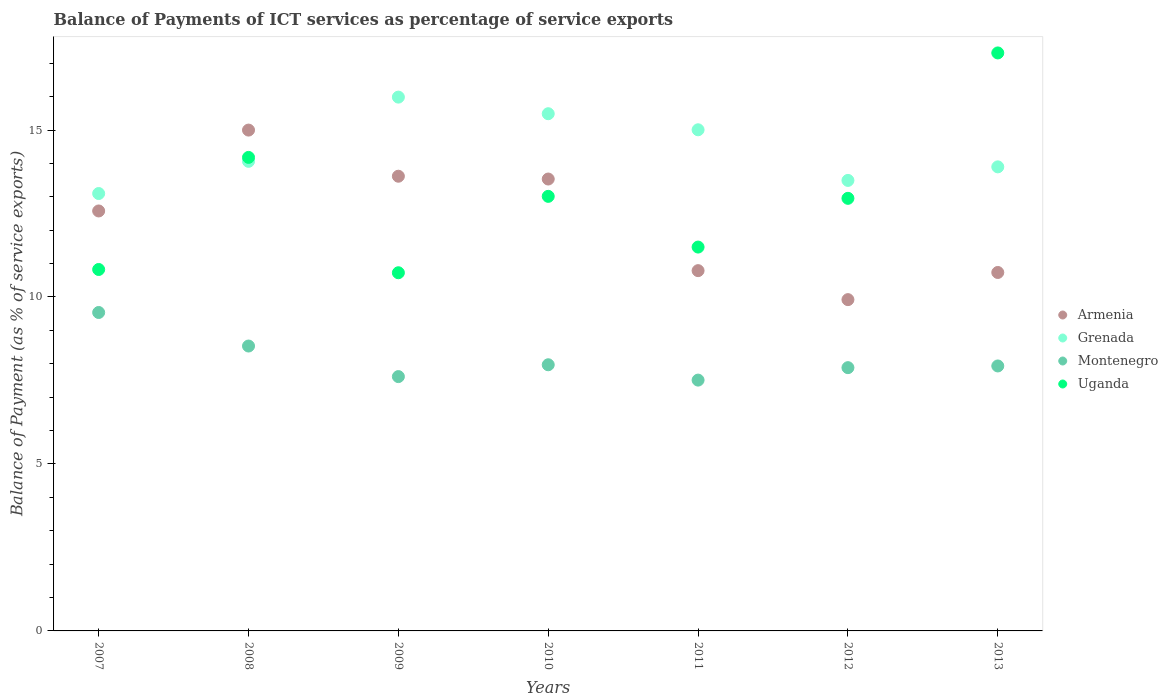How many different coloured dotlines are there?
Your answer should be very brief. 4. What is the balance of payments of ICT services in Uganda in 2013?
Your response must be concise. 17.31. Across all years, what is the maximum balance of payments of ICT services in Armenia?
Provide a short and direct response. 15. Across all years, what is the minimum balance of payments of ICT services in Montenegro?
Provide a short and direct response. 7.51. In which year was the balance of payments of ICT services in Armenia maximum?
Give a very brief answer. 2008. What is the total balance of payments of ICT services in Armenia in the graph?
Offer a very short reply. 86.17. What is the difference between the balance of payments of ICT services in Grenada in 2011 and that in 2012?
Keep it short and to the point. 1.52. What is the difference between the balance of payments of ICT services in Grenada in 2013 and the balance of payments of ICT services in Montenegro in 2007?
Provide a succinct answer. 4.36. What is the average balance of payments of ICT services in Armenia per year?
Your response must be concise. 12.31. In the year 2009, what is the difference between the balance of payments of ICT services in Montenegro and balance of payments of ICT services in Uganda?
Keep it short and to the point. -3.11. In how many years, is the balance of payments of ICT services in Grenada greater than 9 %?
Make the answer very short. 7. What is the ratio of the balance of payments of ICT services in Armenia in 2011 to that in 2012?
Keep it short and to the point. 1.09. Is the balance of payments of ICT services in Grenada in 2009 less than that in 2012?
Make the answer very short. No. Is the difference between the balance of payments of ICT services in Montenegro in 2008 and 2011 greater than the difference between the balance of payments of ICT services in Uganda in 2008 and 2011?
Your answer should be very brief. No. What is the difference between the highest and the second highest balance of payments of ICT services in Grenada?
Provide a short and direct response. 0.5. What is the difference between the highest and the lowest balance of payments of ICT services in Grenada?
Your answer should be compact. 2.89. Is the sum of the balance of payments of ICT services in Uganda in 2009 and 2010 greater than the maximum balance of payments of ICT services in Grenada across all years?
Provide a succinct answer. Yes. Is it the case that in every year, the sum of the balance of payments of ICT services in Montenegro and balance of payments of ICT services in Grenada  is greater than the balance of payments of ICT services in Uganda?
Offer a terse response. Yes. Does the balance of payments of ICT services in Montenegro monotonically increase over the years?
Your answer should be very brief. No. Is the balance of payments of ICT services in Armenia strictly less than the balance of payments of ICT services in Grenada over the years?
Offer a very short reply. No. What is the difference between two consecutive major ticks on the Y-axis?
Give a very brief answer. 5. Are the values on the major ticks of Y-axis written in scientific E-notation?
Your answer should be very brief. No. Where does the legend appear in the graph?
Keep it short and to the point. Center right. What is the title of the graph?
Provide a succinct answer. Balance of Payments of ICT services as percentage of service exports. Does "Hungary" appear as one of the legend labels in the graph?
Your answer should be compact. No. What is the label or title of the Y-axis?
Your answer should be very brief. Balance of Payment (as % of service exports). What is the Balance of Payment (as % of service exports) of Armenia in 2007?
Offer a very short reply. 12.58. What is the Balance of Payment (as % of service exports) of Grenada in 2007?
Offer a terse response. 13.1. What is the Balance of Payment (as % of service exports) of Montenegro in 2007?
Your answer should be compact. 9.54. What is the Balance of Payment (as % of service exports) in Uganda in 2007?
Offer a terse response. 10.82. What is the Balance of Payment (as % of service exports) in Armenia in 2008?
Keep it short and to the point. 15. What is the Balance of Payment (as % of service exports) in Grenada in 2008?
Ensure brevity in your answer.  14.06. What is the Balance of Payment (as % of service exports) in Montenegro in 2008?
Make the answer very short. 8.53. What is the Balance of Payment (as % of service exports) in Uganda in 2008?
Offer a very short reply. 14.18. What is the Balance of Payment (as % of service exports) in Armenia in 2009?
Give a very brief answer. 13.62. What is the Balance of Payment (as % of service exports) in Grenada in 2009?
Ensure brevity in your answer.  15.99. What is the Balance of Payment (as % of service exports) of Montenegro in 2009?
Keep it short and to the point. 7.62. What is the Balance of Payment (as % of service exports) of Uganda in 2009?
Your response must be concise. 10.73. What is the Balance of Payment (as % of service exports) in Armenia in 2010?
Keep it short and to the point. 13.53. What is the Balance of Payment (as % of service exports) in Grenada in 2010?
Keep it short and to the point. 15.49. What is the Balance of Payment (as % of service exports) in Montenegro in 2010?
Offer a terse response. 7.97. What is the Balance of Payment (as % of service exports) of Uganda in 2010?
Give a very brief answer. 13.01. What is the Balance of Payment (as % of service exports) of Armenia in 2011?
Provide a succinct answer. 10.79. What is the Balance of Payment (as % of service exports) in Grenada in 2011?
Your response must be concise. 15.01. What is the Balance of Payment (as % of service exports) of Montenegro in 2011?
Ensure brevity in your answer.  7.51. What is the Balance of Payment (as % of service exports) in Uganda in 2011?
Your answer should be compact. 11.49. What is the Balance of Payment (as % of service exports) in Armenia in 2012?
Ensure brevity in your answer.  9.92. What is the Balance of Payment (as % of service exports) of Grenada in 2012?
Ensure brevity in your answer.  13.49. What is the Balance of Payment (as % of service exports) in Montenegro in 2012?
Provide a succinct answer. 7.88. What is the Balance of Payment (as % of service exports) of Uganda in 2012?
Your response must be concise. 12.95. What is the Balance of Payment (as % of service exports) in Armenia in 2013?
Provide a succinct answer. 10.73. What is the Balance of Payment (as % of service exports) of Grenada in 2013?
Ensure brevity in your answer.  13.9. What is the Balance of Payment (as % of service exports) in Montenegro in 2013?
Provide a short and direct response. 7.93. What is the Balance of Payment (as % of service exports) of Uganda in 2013?
Give a very brief answer. 17.31. Across all years, what is the maximum Balance of Payment (as % of service exports) of Armenia?
Offer a very short reply. 15. Across all years, what is the maximum Balance of Payment (as % of service exports) of Grenada?
Provide a succinct answer. 15.99. Across all years, what is the maximum Balance of Payment (as % of service exports) in Montenegro?
Give a very brief answer. 9.54. Across all years, what is the maximum Balance of Payment (as % of service exports) of Uganda?
Your answer should be compact. 17.31. Across all years, what is the minimum Balance of Payment (as % of service exports) in Armenia?
Keep it short and to the point. 9.92. Across all years, what is the minimum Balance of Payment (as % of service exports) in Grenada?
Offer a very short reply. 13.1. Across all years, what is the minimum Balance of Payment (as % of service exports) in Montenegro?
Provide a succinct answer. 7.51. Across all years, what is the minimum Balance of Payment (as % of service exports) of Uganda?
Your answer should be compact. 10.73. What is the total Balance of Payment (as % of service exports) in Armenia in the graph?
Provide a short and direct response. 86.17. What is the total Balance of Payment (as % of service exports) in Grenada in the graph?
Offer a terse response. 101.03. What is the total Balance of Payment (as % of service exports) in Montenegro in the graph?
Provide a short and direct response. 56.98. What is the total Balance of Payment (as % of service exports) in Uganda in the graph?
Keep it short and to the point. 90.5. What is the difference between the Balance of Payment (as % of service exports) in Armenia in 2007 and that in 2008?
Offer a terse response. -2.42. What is the difference between the Balance of Payment (as % of service exports) in Grenada in 2007 and that in 2008?
Keep it short and to the point. -0.96. What is the difference between the Balance of Payment (as % of service exports) of Montenegro in 2007 and that in 2008?
Keep it short and to the point. 1. What is the difference between the Balance of Payment (as % of service exports) of Uganda in 2007 and that in 2008?
Provide a succinct answer. -3.36. What is the difference between the Balance of Payment (as % of service exports) of Armenia in 2007 and that in 2009?
Ensure brevity in your answer.  -1.04. What is the difference between the Balance of Payment (as % of service exports) in Grenada in 2007 and that in 2009?
Provide a short and direct response. -2.89. What is the difference between the Balance of Payment (as % of service exports) in Montenegro in 2007 and that in 2009?
Provide a succinct answer. 1.92. What is the difference between the Balance of Payment (as % of service exports) in Uganda in 2007 and that in 2009?
Your answer should be compact. 0.1. What is the difference between the Balance of Payment (as % of service exports) of Armenia in 2007 and that in 2010?
Ensure brevity in your answer.  -0.96. What is the difference between the Balance of Payment (as % of service exports) of Grenada in 2007 and that in 2010?
Provide a short and direct response. -2.39. What is the difference between the Balance of Payment (as % of service exports) in Montenegro in 2007 and that in 2010?
Your answer should be very brief. 1.57. What is the difference between the Balance of Payment (as % of service exports) in Uganda in 2007 and that in 2010?
Offer a very short reply. -2.19. What is the difference between the Balance of Payment (as % of service exports) in Armenia in 2007 and that in 2011?
Ensure brevity in your answer.  1.79. What is the difference between the Balance of Payment (as % of service exports) in Grenada in 2007 and that in 2011?
Offer a very short reply. -1.91. What is the difference between the Balance of Payment (as % of service exports) of Montenegro in 2007 and that in 2011?
Offer a terse response. 2.02. What is the difference between the Balance of Payment (as % of service exports) of Uganda in 2007 and that in 2011?
Provide a succinct answer. -0.67. What is the difference between the Balance of Payment (as % of service exports) in Armenia in 2007 and that in 2012?
Provide a succinct answer. 2.66. What is the difference between the Balance of Payment (as % of service exports) of Grenada in 2007 and that in 2012?
Offer a terse response. -0.39. What is the difference between the Balance of Payment (as % of service exports) of Montenegro in 2007 and that in 2012?
Give a very brief answer. 1.65. What is the difference between the Balance of Payment (as % of service exports) in Uganda in 2007 and that in 2012?
Ensure brevity in your answer.  -2.13. What is the difference between the Balance of Payment (as % of service exports) of Armenia in 2007 and that in 2013?
Offer a terse response. 1.84. What is the difference between the Balance of Payment (as % of service exports) in Grenada in 2007 and that in 2013?
Your response must be concise. -0.8. What is the difference between the Balance of Payment (as % of service exports) in Montenegro in 2007 and that in 2013?
Your response must be concise. 1.6. What is the difference between the Balance of Payment (as % of service exports) of Uganda in 2007 and that in 2013?
Provide a succinct answer. -6.49. What is the difference between the Balance of Payment (as % of service exports) in Armenia in 2008 and that in 2009?
Keep it short and to the point. 1.38. What is the difference between the Balance of Payment (as % of service exports) in Grenada in 2008 and that in 2009?
Keep it short and to the point. -1.92. What is the difference between the Balance of Payment (as % of service exports) of Montenegro in 2008 and that in 2009?
Offer a terse response. 0.92. What is the difference between the Balance of Payment (as % of service exports) in Uganda in 2008 and that in 2009?
Your response must be concise. 3.45. What is the difference between the Balance of Payment (as % of service exports) of Armenia in 2008 and that in 2010?
Your answer should be very brief. 1.47. What is the difference between the Balance of Payment (as % of service exports) in Grenada in 2008 and that in 2010?
Provide a short and direct response. -1.43. What is the difference between the Balance of Payment (as % of service exports) of Montenegro in 2008 and that in 2010?
Give a very brief answer. 0.56. What is the difference between the Balance of Payment (as % of service exports) of Armenia in 2008 and that in 2011?
Your response must be concise. 4.21. What is the difference between the Balance of Payment (as % of service exports) of Grenada in 2008 and that in 2011?
Your response must be concise. -0.94. What is the difference between the Balance of Payment (as % of service exports) in Montenegro in 2008 and that in 2011?
Your answer should be very brief. 1.02. What is the difference between the Balance of Payment (as % of service exports) in Uganda in 2008 and that in 2011?
Your answer should be compact. 2.69. What is the difference between the Balance of Payment (as % of service exports) of Armenia in 2008 and that in 2012?
Offer a terse response. 5.08. What is the difference between the Balance of Payment (as % of service exports) in Grenada in 2008 and that in 2012?
Keep it short and to the point. 0.57. What is the difference between the Balance of Payment (as % of service exports) in Montenegro in 2008 and that in 2012?
Keep it short and to the point. 0.65. What is the difference between the Balance of Payment (as % of service exports) of Uganda in 2008 and that in 2012?
Provide a succinct answer. 1.23. What is the difference between the Balance of Payment (as % of service exports) in Armenia in 2008 and that in 2013?
Offer a terse response. 4.26. What is the difference between the Balance of Payment (as % of service exports) in Grenada in 2008 and that in 2013?
Your answer should be very brief. 0.17. What is the difference between the Balance of Payment (as % of service exports) in Montenegro in 2008 and that in 2013?
Make the answer very short. 0.6. What is the difference between the Balance of Payment (as % of service exports) in Uganda in 2008 and that in 2013?
Give a very brief answer. -3.13. What is the difference between the Balance of Payment (as % of service exports) of Armenia in 2009 and that in 2010?
Your answer should be very brief. 0.08. What is the difference between the Balance of Payment (as % of service exports) of Grenada in 2009 and that in 2010?
Your answer should be very brief. 0.5. What is the difference between the Balance of Payment (as % of service exports) of Montenegro in 2009 and that in 2010?
Your answer should be compact. -0.35. What is the difference between the Balance of Payment (as % of service exports) in Uganda in 2009 and that in 2010?
Give a very brief answer. -2.29. What is the difference between the Balance of Payment (as % of service exports) of Armenia in 2009 and that in 2011?
Give a very brief answer. 2.83. What is the difference between the Balance of Payment (as % of service exports) of Grenada in 2009 and that in 2011?
Offer a very short reply. 0.98. What is the difference between the Balance of Payment (as % of service exports) in Montenegro in 2009 and that in 2011?
Your response must be concise. 0.11. What is the difference between the Balance of Payment (as % of service exports) in Uganda in 2009 and that in 2011?
Give a very brief answer. -0.77. What is the difference between the Balance of Payment (as % of service exports) of Armenia in 2009 and that in 2012?
Provide a short and direct response. 3.7. What is the difference between the Balance of Payment (as % of service exports) of Grenada in 2009 and that in 2012?
Keep it short and to the point. 2.49. What is the difference between the Balance of Payment (as % of service exports) of Montenegro in 2009 and that in 2012?
Provide a short and direct response. -0.27. What is the difference between the Balance of Payment (as % of service exports) of Uganda in 2009 and that in 2012?
Your answer should be compact. -2.23. What is the difference between the Balance of Payment (as % of service exports) of Armenia in 2009 and that in 2013?
Your response must be concise. 2.88. What is the difference between the Balance of Payment (as % of service exports) of Grenada in 2009 and that in 2013?
Provide a succinct answer. 2.09. What is the difference between the Balance of Payment (as % of service exports) in Montenegro in 2009 and that in 2013?
Keep it short and to the point. -0.32. What is the difference between the Balance of Payment (as % of service exports) of Uganda in 2009 and that in 2013?
Offer a very short reply. -6.58. What is the difference between the Balance of Payment (as % of service exports) in Armenia in 2010 and that in 2011?
Offer a terse response. 2.74. What is the difference between the Balance of Payment (as % of service exports) in Grenada in 2010 and that in 2011?
Make the answer very short. 0.48. What is the difference between the Balance of Payment (as % of service exports) in Montenegro in 2010 and that in 2011?
Make the answer very short. 0.46. What is the difference between the Balance of Payment (as % of service exports) in Uganda in 2010 and that in 2011?
Make the answer very short. 1.52. What is the difference between the Balance of Payment (as % of service exports) in Armenia in 2010 and that in 2012?
Make the answer very short. 3.61. What is the difference between the Balance of Payment (as % of service exports) in Grenada in 2010 and that in 2012?
Keep it short and to the point. 2. What is the difference between the Balance of Payment (as % of service exports) of Montenegro in 2010 and that in 2012?
Your answer should be very brief. 0.09. What is the difference between the Balance of Payment (as % of service exports) of Uganda in 2010 and that in 2012?
Make the answer very short. 0.06. What is the difference between the Balance of Payment (as % of service exports) in Armenia in 2010 and that in 2013?
Your answer should be very brief. 2.8. What is the difference between the Balance of Payment (as % of service exports) of Grenada in 2010 and that in 2013?
Your answer should be compact. 1.59. What is the difference between the Balance of Payment (as % of service exports) of Montenegro in 2010 and that in 2013?
Your response must be concise. 0.04. What is the difference between the Balance of Payment (as % of service exports) in Uganda in 2010 and that in 2013?
Ensure brevity in your answer.  -4.29. What is the difference between the Balance of Payment (as % of service exports) in Armenia in 2011 and that in 2012?
Provide a succinct answer. 0.87. What is the difference between the Balance of Payment (as % of service exports) in Grenada in 2011 and that in 2012?
Give a very brief answer. 1.52. What is the difference between the Balance of Payment (as % of service exports) in Montenegro in 2011 and that in 2012?
Provide a short and direct response. -0.37. What is the difference between the Balance of Payment (as % of service exports) in Uganda in 2011 and that in 2012?
Offer a very short reply. -1.46. What is the difference between the Balance of Payment (as % of service exports) in Armenia in 2011 and that in 2013?
Keep it short and to the point. 0.05. What is the difference between the Balance of Payment (as % of service exports) in Grenada in 2011 and that in 2013?
Offer a very short reply. 1.11. What is the difference between the Balance of Payment (as % of service exports) of Montenegro in 2011 and that in 2013?
Offer a very short reply. -0.42. What is the difference between the Balance of Payment (as % of service exports) in Uganda in 2011 and that in 2013?
Ensure brevity in your answer.  -5.81. What is the difference between the Balance of Payment (as % of service exports) in Armenia in 2012 and that in 2013?
Offer a terse response. -0.81. What is the difference between the Balance of Payment (as % of service exports) in Grenada in 2012 and that in 2013?
Offer a very short reply. -0.41. What is the difference between the Balance of Payment (as % of service exports) in Montenegro in 2012 and that in 2013?
Provide a short and direct response. -0.05. What is the difference between the Balance of Payment (as % of service exports) of Uganda in 2012 and that in 2013?
Your response must be concise. -4.35. What is the difference between the Balance of Payment (as % of service exports) of Armenia in 2007 and the Balance of Payment (as % of service exports) of Grenada in 2008?
Your answer should be compact. -1.49. What is the difference between the Balance of Payment (as % of service exports) in Armenia in 2007 and the Balance of Payment (as % of service exports) in Montenegro in 2008?
Provide a short and direct response. 4.04. What is the difference between the Balance of Payment (as % of service exports) in Armenia in 2007 and the Balance of Payment (as % of service exports) in Uganda in 2008?
Give a very brief answer. -1.6. What is the difference between the Balance of Payment (as % of service exports) of Grenada in 2007 and the Balance of Payment (as % of service exports) of Montenegro in 2008?
Offer a very short reply. 4.57. What is the difference between the Balance of Payment (as % of service exports) in Grenada in 2007 and the Balance of Payment (as % of service exports) in Uganda in 2008?
Make the answer very short. -1.08. What is the difference between the Balance of Payment (as % of service exports) in Montenegro in 2007 and the Balance of Payment (as % of service exports) in Uganda in 2008?
Give a very brief answer. -4.64. What is the difference between the Balance of Payment (as % of service exports) of Armenia in 2007 and the Balance of Payment (as % of service exports) of Grenada in 2009?
Your response must be concise. -3.41. What is the difference between the Balance of Payment (as % of service exports) in Armenia in 2007 and the Balance of Payment (as % of service exports) in Montenegro in 2009?
Provide a short and direct response. 4.96. What is the difference between the Balance of Payment (as % of service exports) of Armenia in 2007 and the Balance of Payment (as % of service exports) of Uganda in 2009?
Offer a very short reply. 1.85. What is the difference between the Balance of Payment (as % of service exports) of Grenada in 2007 and the Balance of Payment (as % of service exports) of Montenegro in 2009?
Your answer should be very brief. 5.48. What is the difference between the Balance of Payment (as % of service exports) in Grenada in 2007 and the Balance of Payment (as % of service exports) in Uganda in 2009?
Your answer should be very brief. 2.37. What is the difference between the Balance of Payment (as % of service exports) in Montenegro in 2007 and the Balance of Payment (as % of service exports) in Uganda in 2009?
Your answer should be very brief. -1.19. What is the difference between the Balance of Payment (as % of service exports) of Armenia in 2007 and the Balance of Payment (as % of service exports) of Grenada in 2010?
Provide a short and direct response. -2.91. What is the difference between the Balance of Payment (as % of service exports) of Armenia in 2007 and the Balance of Payment (as % of service exports) of Montenegro in 2010?
Make the answer very short. 4.61. What is the difference between the Balance of Payment (as % of service exports) in Armenia in 2007 and the Balance of Payment (as % of service exports) in Uganda in 2010?
Provide a succinct answer. -0.44. What is the difference between the Balance of Payment (as % of service exports) in Grenada in 2007 and the Balance of Payment (as % of service exports) in Montenegro in 2010?
Keep it short and to the point. 5.13. What is the difference between the Balance of Payment (as % of service exports) in Grenada in 2007 and the Balance of Payment (as % of service exports) in Uganda in 2010?
Your answer should be compact. 0.08. What is the difference between the Balance of Payment (as % of service exports) in Montenegro in 2007 and the Balance of Payment (as % of service exports) in Uganda in 2010?
Ensure brevity in your answer.  -3.48. What is the difference between the Balance of Payment (as % of service exports) of Armenia in 2007 and the Balance of Payment (as % of service exports) of Grenada in 2011?
Provide a succinct answer. -2.43. What is the difference between the Balance of Payment (as % of service exports) in Armenia in 2007 and the Balance of Payment (as % of service exports) in Montenegro in 2011?
Provide a succinct answer. 5.07. What is the difference between the Balance of Payment (as % of service exports) in Armenia in 2007 and the Balance of Payment (as % of service exports) in Uganda in 2011?
Your response must be concise. 1.08. What is the difference between the Balance of Payment (as % of service exports) of Grenada in 2007 and the Balance of Payment (as % of service exports) of Montenegro in 2011?
Offer a terse response. 5.59. What is the difference between the Balance of Payment (as % of service exports) of Grenada in 2007 and the Balance of Payment (as % of service exports) of Uganda in 2011?
Provide a short and direct response. 1.6. What is the difference between the Balance of Payment (as % of service exports) of Montenegro in 2007 and the Balance of Payment (as % of service exports) of Uganda in 2011?
Offer a very short reply. -1.96. What is the difference between the Balance of Payment (as % of service exports) of Armenia in 2007 and the Balance of Payment (as % of service exports) of Grenada in 2012?
Your answer should be very brief. -0.91. What is the difference between the Balance of Payment (as % of service exports) in Armenia in 2007 and the Balance of Payment (as % of service exports) in Montenegro in 2012?
Give a very brief answer. 4.69. What is the difference between the Balance of Payment (as % of service exports) of Armenia in 2007 and the Balance of Payment (as % of service exports) of Uganda in 2012?
Provide a short and direct response. -0.38. What is the difference between the Balance of Payment (as % of service exports) of Grenada in 2007 and the Balance of Payment (as % of service exports) of Montenegro in 2012?
Provide a short and direct response. 5.21. What is the difference between the Balance of Payment (as % of service exports) in Grenada in 2007 and the Balance of Payment (as % of service exports) in Uganda in 2012?
Ensure brevity in your answer.  0.14. What is the difference between the Balance of Payment (as % of service exports) in Montenegro in 2007 and the Balance of Payment (as % of service exports) in Uganda in 2012?
Provide a succinct answer. -3.42. What is the difference between the Balance of Payment (as % of service exports) of Armenia in 2007 and the Balance of Payment (as % of service exports) of Grenada in 2013?
Your response must be concise. -1.32. What is the difference between the Balance of Payment (as % of service exports) of Armenia in 2007 and the Balance of Payment (as % of service exports) of Montenegro in 2013?
Offer a very short reply. 4.64. What is the difference between the Balance of Payment (as % of service exports) of Armenia in 2007 and the Balance of Payment (as % of service exports) of Uganda in 2013?
Ensure brevity in your answer.  -4.73. What is the difference between the Balance of Payment (as % of service exports) in Grenada in 2007 and the Balance of Payment (as % of service exports) in Montenegro in 2013?
Your response must be concise. 5.16. What is the difference between the Balance of Payment (as % of service exports) of Grenada in 2007 and the Balance of Payment (as % of service exports) of Uganda in 2013?
Offer a terse response. -4.21. What is the difference between the Balance of Payment (as % of service exports) of Montenegro in 2007 and the Balance of Payment (as % of service exports) of Uganda in 2013?
Your response must be concise. -7.77. What is the difference between the Balance of Payment (as % of service exports) in Armenia in 2008 and the Balance of Payment (as % of service exports) in Grenada in 2009?
Your response must be concise. -0.99. What is the difference between the Balance of Payment (as % of service exports) in Armenia in 2008 and the Balance of Payment (as % of service exports) in Montenegro in 2009?
Ensure brevity in your answer.  7.38. What is the difference between the Balance of Payment (as % of service exports) of Armenia in 2008 and the Balance of Payment (as % of service exports) of Uganda in 2009?
Your answer should be very brief. 4.27. What is the difference between the Balance of Payment (as % of service exports) in Grenada in 2008 and the Balance of Payment (as % of service exports) in Montenegro in 2009?
Provide a succinct answer. 6.45. What is the difference between the Balance of Payment (as % of service exports) in Grenada in 2008 and the Balance of Payment (as % of service exports) in Uganda in 2009?
Offer a very short reply. 3.34. What is the difference between the Balance of Payment (as % of service exports) in Montenegro in 2008 and the Balance of Payment (as % of service exports) in Uganda in 2009?
Keep it short and to the point. -2.19. What is the difference between the Balance of Payment (as % of service exports) in Armenia in 2008 and the Balance of Payment (as % of service exports) in Grenada in 2010?
Your response must be concise. -0.49. What is the difference between the Balance of Payment (as % of service exports) in Armenia in 2008 and the Balance of Payment (as % of service exports) in Montenegro in 2010?
Give a very brief answer. 7.03. What is the difference between the Balance of Payment (as % of service exports) of Armenia in 2008 and the Balance of Payment (as % of service exports) of Uganda in 2010?
Offer a very short reply. 1.98. What is the difference between the Balance of Payment (as % of service exports) in Grenada in 2008 and the Balance of Payment (as % of service exports) in Montenegro in 2010?
Keep it short and to the point. 6.09. What is the difference between the Balance of Payment (as % of service exports) of Grenada in 2008 and the Balance of Payment (as % of service exports) of Uganda in 2010?
Make the answer very short. 1.05. What is the difference between the Balance of Payment (as % of service exports) of Montenegro in 2008 and the Balance of Payment (as % of service exports) of Uganda in 2010?
Your answer should be compact. -4.48. What is the difference between the Balance of Payment (as % of service exports) of Armenia in 2008 and the Balance of Payment (as % of service exports) of Grenada in 2011?
Provide a succinct answer. -0.01. What is the difference between the Balance of Payment (as % of service exports) in Armenia in 2008 and the Balance of Payment (as % of service exports) in Montenegro in 2011?
Provide a succinct answer. 7.49. What is the difference between the Balance of Payment (as % of service exports) of Armenia in 2008 and the Balance of Payment (as % of service exports) of Uganda in 2011?
Keep it short and to the point. 3.5. What is the difference between the Balance of Payment (as % of service exports) of Grenada in 2008 and the Balance of Payment (as % of service exports) of Montenegro in 2011?
Keep it short and to the point. 6.55. What is the difference between the Balance of Payment (as % of service exports) in Grenada in 2008 and the Balance of Payment (as % of service exports) in Uganda in 2011?
Keep it short and to the point. 2.57. What is the difference between the Balance of Payment (as % of service exports) of Montenegro in 2008 and the Balance of Payment (as % of service exports) of Uganda in 2011?
Your response must be concise. -2.96. What is the difference between the Balance of Payment (as % of service exports) in Armenia in 2008 and the Balance of Payment (as % of service exports) in Grenada in 2012?
Offer a terse response. 1.51. What is the difference between the Balance of Payment (as % of service exports) in Armenia in 2008 and the Balance of Payment (as % of service exports) in Montenegro in 2012?
Offer a terse response. 7.11. What is the difference between the Balance of Payment (as % of service exports) in Armenia in 2008 and the Balance of Payment (as % of service exports) in Uganda in 2012?
Provide a succinct answer. 2.04. What is the difference between the Balance of Payment (as % of service exports) in Grenada in 2008 and the Balance of Payment (as % of service exports) in Montenegro in 2012?
Your answer should be very brief. 6.18. What is the difference between the Balance of Payment (as % of service exports) of Grenada in 2008 and the Balance of Payment (as % of service exports) of Uganda in 2012?
Offer a very short reply. 1.11. What is the difference between the Balance of Payment (as % of service exports) of Montenegro in 2008 and the Balance of Payment (as % of service exports) of Uganda in 2012?
Provide a succinct answer. -4.42. What is the difference between the Balance of Payment (as % of service exports) in Armenia in 2008 and the Balance of Payment (as % of service exports) in Grenada in 2013?
Give a very brief answer. 1.1. What is the difference between the Balance of Payment (as % of service exports) of Armenia in 2008 and the Balance of Payment (as % of service exports) of Montenegro in 2013?
Provide a short and direct response. 7.06. What is the difference between the Balance of Payment (as % of service exports) of Armenia in 2008 and the Balance of Payment (as % of service exports) of Uganda in 2013?
Offer a terse response. -2.31. What is the difference between the Balance of Payment (as % of service exports) of Grenada in 2008 and the Balance of Payment (as % of service exports) of Montenegro in 2013?
Offer a terse response. 6.13. What is the difference between the Balance of Payment (as % of service exports) in Grenada in 2008 and the Balance of Payment (as % of service exports) in Uganda in 2013?
Your answer should be very brief. -3.25. What is the difference between the Balance of Payment (as % of service exports) of Montenegro in 2008 and the Balance of Payment (as % of service exports) of Uganda in 2013?
Your response must be concise. -8.78. What is the difference between the Balance of Payment (as % of service exports) in Armenia in 2009 and the Balance of Payment (as % of service exports) in Grenada in 2010?
Your response must be concise. -1.87. What is the difference between the Balance of Payment (as % of service exports) in Armenia in 2009 and the Balance of Payment (as % of service exports) in Montenegro in 2010?
Provide a short and direct response. 5.65. What is the difference between the Balance of Payment (as % of service exports) of Armenia in 2009 and the Balance of Payment (as % of service exports) of Uganda in 2010?
Provide a succinct answer. 0.6. What is the difference between the Balance of Payment (as % of service exports) of Grenada in 2009 and the Balance of Payment (as % of service exports) of Montenegro in 2010?
Your response must be concise. 8.02. What is the difference between the Balance of Payment (as % of service exports) in Grenada in 2009 and the Balance of Payment (as % of service exports) in Uganda in 2010?
Give a very brief answer. 2.97. What is the difference between the Balance of Payment (as % of service exports) in Montenegro in 2009 and the Balance of Payment (as % of service exports) in Uganda in 2010?
Offer a terse response. -5.4. What is the difference between the Balance of Payment (as % of service exports) in Armenia in 2009 and the Balance of Payment (as % of service exports) in Grenada in 2011?
Your answer should be compact. -1.39. What is the difference between the Balance of Payment (as % of service exports) of Armenia in 2009 and the Balance of Payment (as % of service exports) of Montenegro in 2011?
Ensure brevity in your answer.  6.11. What is the difference between the Balance of Payment (as % of service exports) of Armenia in 2009 and the Balance of Payment (as % of service exports) of Uganda in 2011?
Your answer should be compact. 2.12. What is the difference between the Balance of Payment (as % of service exports) in Grenada in 2009 and the Balance of Payment (as % of service exports) in Montenegro in 2011?
Give a very brief answer. 8.47. What is the difference between the Balance of Payment (as % of service exports) of Grenada in 2009 and the Balance of Payment (as % of service exports) of Uganda in 2011?
Provide a succinct answer. 4.49. What is the difference between the Balance of Payment (as % of service exports) of Montenegro in 2009 and the Balance of Payment (as % of service exports) of Uganda in 2011?
Your response must be concise. -3.88. What is the difference between the Balance of Payment (as % of service exports) in Armenia in 2009 and the Balance of Payment (as % of service exports) in Grenada in 2012?
Provide a succinct answer. 0.13. What is the difference between the Balance of Payment (as % of service exports) in Armenia in 2009 and the Balance of Payment (as % of service exports) in Montenegro in 2012?
Your response must be concise. 5.73. What is the difference between the Balance of Payment (as % of service exports) in Armenia in 2009 and the Balance of Payment (as % of service exports) in Uganda in 2012?
Ensure brevity in your answer.  0.66. What is the difference between the Balance of Payment (as % of service exports) in Grenada in 2009 and the Balance of Payment (as % of service exports) in Montenegro in 2012?
Your answer should be compact. 8.1. What is the difference between the Balance of Payment (as % of service exports) in Grenada in 2009 and the Balance of Payment (as % of service exports) in Uganda in 2012?
Ensure brevity in your answer.  3.03. What is the difference between the Balance of Payment (as % of service exports) of Montenegro in 2009 and the Balance of Payment (as % of service exports) of Uganda in 2012?
Your response must be concise. -5.34. What is the difference between the Balance of Payment (as % of service exports) in Armenia in 2009 and the Balance of Payment (as % of service exports) in Grenada in 2013?
Provide a succinct answer. -0.28. What is the difference between the Balance of Payment (as % of service exports) of Armenia in 2009 and the Balance of Payment (as % of service exports) of Montenegro in 2013?
Ensure brevity in your answer.  5.68. What is the difference between the Balance of Payment (as % of service exports) of Armenia in 2009 and the Balance of Payment (as % of service exports) of Uganda in 2013?
Provide a short and direct response. -3.69. What is the difference between the Balance of Payment (as % of service exports) of Grenada in 2009 and the Balance of Payment (as % of service exports) of Montenegro in 2013?
Ensure brevity in your answer.  8.05. What is the difference between the Balance of Payment (as % of service exports) in Grenada in 2009 and the Balance of Payment (as % of service exports) in Uganda in 2013?
Your response must be concise. -1.32. What is the difference between the Balance of Payment (as % of service exports) in Montenegro in 2009 and the Balance of Payment (as % of service exports) in Uganda in 2013?
Keep it short and to the point. -9.69. What is the difference between the Balance of Payment (as % of service exports) in Armenia in 2010 and the Balance of Payment (as % of service exports) in Grenada in 2011?
Keep it short and to the point. -1.47. What is the difference between the Balance of Payment (as % of service exports) in Armenia in 2010 and the Balance of Payment (as % of service exports) in Montenegro in 2011?
Offer a very short reply. 6.02. What is the difference between the Balance of Payment (as % of service exports) of Armenia in 2010 and the Balance of Payment (as % of service exports) of Uganda in 2011?
Offer a terse response. 2.04. What is the difference between the Balance of Payment (as % of service exports) in Grenada in 2010 and the Balance of Payment (as % of service exports) in Montenegro in 2011?
Ensure brevity in your answer.  7.98. What is the difference between the Balance of Payment (as % of service exports) of Grenada in 2010 and the Balance of Payment (as % of service exports) of Uganda in 2011?
Your response must be concise. 3.99. What is the difference between the Balance of Payment (as % of service exports) of Montenegro in 2010 and the Balance of Payment (as % of service exports) of Uganda in 2011?
Your answer should be compact. -3.52. What is the difference between the Balance of Payment (as % of service exports) in Armenia in 2010 and the Balance of Payment (as % of service exports) in Grenada in 2012?
Ensure brevity in your answer.  0.04. What is the difference between the Balance of Payment (as % of service exports) in Armenia in 2010 and the Balance of Payment (as % of service exports) in Montenegro in 2012?
Provide a succinct answer. 5.65. What is the difference between the Balance of Payment (as % of service exports) in Armenia in 2010 and the Balance of Payment (as % of service exports) in Uganda in 2012?
Your answer should be compact. 0.58. What is the difference between the Balance of Payment (as % of service exports) in Grenada in 2010 and the Balance of Payment (as % of service exports) in Montenegro in 2012?
Offer a terse response. 7.6. What is the difference between the Balance of Payment (as % of service exports) in Grenada in 2010 and the Balance of Payment (as % of service exports) in Uganda in 2012?
Your answer should be compact. 2.53. What is the difference between the Balance of Payment (as % of service exports) of Montenegro in 2010 and the Balance of Payment (as % of service exports) of Uganda in 2012?
Your answer should be very brief. -4.98. What is the difference between the Balance of Payment (as % of service exports) of Armenia in 2010 and the Balance of Payment (as % of service exports) of Grenada in 2013?
Provide a succinct answer. -0.36. What is the difference between the Balance of Payment (as % of service exports) of Armenia in 2010 and the Balance of Payment (as % of service exports) of Montenegro in 2013?
Your response must be concise. 5.6. What is the difference between the Balance of Payment (as % of service exports) of Armenia in 2010 and the Balance of Payment (as % of service exports) of Uganda in 2013?
Offer a terse response. -3.78. What is the difference between the Balance of Payment (as % of service exports) in Grenada in 2010 and the Balance of Payment (as % of service exports) in Montenegro in 2013?
Keep it short and to the point. 7.55. What is the difference between the Balance of Payment (as % of service exports) in Grenada in 2010 and the Balance of Payment (as % of service exports) in Uganda in 2013?
Your response must be concise. -1.82. What is the difference between the Balance of Payment (as % of service exports) of Montenegro in 2010 and the Balance of Payment (as % of service exports) of Uganda in 2013?
Your answer should be compact. -9.34. What is the difference between the Balance of Payment (as % of service exports) of Armenia in 2011 and the Balance of Payment (as % of service exports) of Grenada in 2012?
Give a very brief answer. -2.7. What is the difference between the Balance of Payment (as % of service exports) of Armenia in 2011 and the Balance of Payment (as % of service exports) of Montenegro in 2012?
Provide a short and direct response. 2.91. What is the difference between the Balance of Payment (as % of service exports) in Armenia in 2011 and the Balance of Payment (as % of service exports) in Uganda in 2012?
Your answer should be compact. -2.17. What is the difference between the Balance of Payment (as % of service exports) of Grenada in 2011 and the Balance of Payment (as % of service exports) of Montenegro in 2012?
Make the answer very short. 7.12. What is the difference between the Balance of Payment (as % of service exports) of Grenada in 2011 and the Balance of Payment (as % of service exports) of Uganda in 2012?
Provide a short and direct response. 2.05. What is the difference between the Balance of Payment (as % of service exports) of Montenegro in 2011 and the Balance of Payment (as % of service exports) of Uganda in 2012?
Provide a short and direct response. -5.44. What is the difference between the Balance of Payment (as % of service exports) of Armenia in 2011 and the Balance of Payment (as % of service exports) of Grenada in 2013?
Provide a short and direct response. -3.11. What is the difference between the Balance of Payment (as % of service exports) of Armenia in 2011 and the Balance of Payment (as % of service exports) of Montenegro in 2013?
Give a very brief answer. 2.85. What is the difference between the Balance of Payment (as % of service exports) in Armenia in 2011 and the Balance of Payment (as % of service exports) in Uganda in 2013?
Keep it short and to the point. -6.52. What is the difference between the Balance of Payment (as % of service exports) in Grenada in 2011 and the Balance of Payment (as % of service exports) in Montenegro in 2013?
Keep it short and to the point. 7.07. What is the difference between the Balance of Payment (as % of service exports) in Grenada in 2011 and the Balance of Payment (as % of service exports) in Uganda in 2013?
Your response must be concise. -2.3. What is the difference between the Balance of Payment (as % of service exports) in Montenegro in 2011 and the Balance of Payment (as % of service exports) in Uganda in 2013?
Offer a very short reply. -9.8. What is the difference between the Balance of Payment (as % of service exports) of Armenia in 2012 and the Balance of Payment (as % of service exports) of Grenada in 2013?
Offer a terse response. -3.98. What is the difference between the Balance of Payment (as % of service exports) in Armenia in 2012 and the Balance of Payment (as % of service exports) in Montenegro in 2013?
Your response must be concise. 1.99. What is the difference between the Balance of Payment (as % of service exports) in Armenia in 2012 and the Balance of Payment (as % of service exports) in Uganda in 2013?
Offer a terse response. -7.39. What is the difference between the Balance of Payment (as % of service exports) of Grenada in 2012 and the Balance of Payment (as % of service exports) of Montenegro in 2013?
Provide a succinct answer. 5.56. What is the difference between the Balance of Payment (as % of service exports) of Grenada in 2012 and the Balance of Payment (as % of service exports) of Uganda in 2013?
Offer a very short reply. -3.82. What is the difference between the Balance of Payment (as % of service exports) of Montenegro in 2012 and the Balance of Payment (as % of service exports) of Uganda in 2013?
Make the answer very short. -9.42. What is the average Balance of Payment (as % of service exports) in Armenia per year?
Make the answer very short. 12.31. What is the average Balance of Payment (as % of service exports) of Grenada per year?
Provide a succinct answer. 14.43. What is the average Balance of Payment (as % of service exports) of Montenegro per year?
Give a very brief answer. 8.14. What is the average Balance of Payment (as % of service exports) in Uganda per year?
Provide a succinct answer. 12.93. In the year 2007, what is the difference between the Balance of Payment (as % of service exports) in Armenia and Balance of Payment (as % of service exports) in Grenada?
Provide a short and direct response. -0.52. In the year 2007, what is the difference between the Balance of Payment (as % of service exports) of Armenia and Balance of Payment (as % of service exports) of Montenegro?
Provide a short and direct response. 3.04. In the year 2007, what is the difference between the Balance of Payment (as % of service exports) in Armenia and Balance of Payment (as % of service exports) in Uganda?
Offer a terse response. 1.75. In the year 2007, what is the difference between the Balance of Payment (as % of service exports) in Grenada and Balance of Payment (as % of service exports) in Montenegro?
Offer a very short reply. 3.56. In the year 2007, what is the difference between the Balance of Payment (as % of service exports) of Grenada and Balance of Payment (as % of service exports) of Uganda?
Keep it short and to the point. 2.27. In the year 2007, what is the difference between the Balance of Payment (as % of service exports) in Montenegro and Balance of Payment (as % of service exports) in Uganda?
Provide a succinct answer. -1.29. In the year 2008, what is the difference between the Balance of Payment (as % of service exports) of Armenia and Balance of Payment (as % of service exports) of Grenada?
Keep it short and to the point. 0.94. In the year 2008, what is the difference between the Balance of Payment (as % of service exports) of Armenia and Balance of Payment (as % of service exports) of Montenegro?
Provide a succinct answer. 6.47. In the year 2008, what is the difference between the Balance of Payment (as % of service exports) in Armenia and Balance of Payment (as % of service exports) in Uganda?
Give a very brief answer. 0.82. In the year 2008, what is the difference between the Balance of Payment (as % of service exports) of Grenada and Balance of Payment (as % of service exports) of Montenegro?
Give a very brief answer. 5.53. In the year 2008, what is the difference between the Balance of Payment (as % of service exports) of Grenada and Balance of Payment (as % of service exports) of Uganda?
Your response must be concise. -0.12. In the year 2008, what is the difference between the Balance of Payment (as % of service exports) of Montenegro and Balance of Payment (as % of service exports) of Uganda?
Offer a very short reply. -5.65. In the year 2009, what is the difference between the Balance of Payment (as % of service exports) of Armenia and Balance of Payment (as % of service exports) of Grenada?
Provide a succinct answer. -2.37. In the year 2009, what is the difference between the Balance of Payment (as % of service exports) of Armenia and Balance of Payment (as % of service exports) of Montenegro?
Provide a succinct answer. 6. In the year 2009, what is the difference between the Balance of Payment (as % of service exports) in Armenia and Balance of Payment (as % of service exports) in Uganda?
Your response must be concise. 2.89. In the year 2009, what is the difference between the Balance of Payment (as % of service exports) in Grenada and Balance of Payment (as % of service exports) in Montenegro?
Provide a succinct answer. 8.37. In the year 2009, what is the difference between the Balance of Payment (as % of service exports) in Grenada and Balance of Payment (as % of service exports) in Uganda?
Your answer should be very brief. 5.26. In the year 2009, what is the difference between the Balance of Payment (as % of service exports) in Montenegro and Balance of Payment (as % of service exports) in Uganda?
Make the answer very short. -3.11. In the year 2010, what is the difference between the Balance of Payment (as % of service exports) in Armenia and Balance of Payment (as % of service exports) in Grenada?
Your answer should be very brief. -1.96. In the year 2010, what is the difference between the Balance of Payment (as % of service exports) in Armenia and Balance of Payment (as % of service exports) in Montenegro?
Offer a very short reply. 5.56. In the year 2010, what is the difference between the Balance of Payment (as % of service exports) in Armenia and Balance of Payment (as % of service exports) in Uganda?
Make the answer very short. 0.52. In the year 2010, what is the difference between the Balance of Payment (as % of service exports) in Grenada and Balance of Payment (as % of service exports) in Montenegro?
Keep it short and to the point. 7.52. In the year 2010, what is the difference between the Balance of Payment (as % of service exports) of Grenada and Balance of Payment (as % of service exports) of Uganda?
Give a very brief answer. 2.47. In the year 2010, what is the difference between the Balance of Payment (as % of service exports) of Montenegro and Balance of Payment (as % of service exports) of Uganda?
Ensure brevity in your answer.  -5.04. In the year 2011, what is the difference between the Balance of Payment (as % of service exports) in Armenia and Balance of Payment (as % of service exports) in Grenada?
Make the answer very short. -4.22. In the year 2011, what is the difference between the Balance of Payment (as % of service exports) of Armenia and Balance of Payment (as % of service exports) of Montenegro?
Keep it short and to the point. 3.28. In the year 2011, what is the difference between the Balance of Payment (as % of service exports) of Armenia and Balance of Payment (as % of service exports) of Uganda?
Provide a short and direct response. -0.71. In the year 2011, what is the difference between the Balance of Payment (as % of service exports) of Grenada and Balance of Payment (as % of service exports) of Montenegro?
Your response must be concise. 7.5. In the year 2011, what is the difference between the Balance of Payment (as % of service exports) in Grenada and Balance of Payment (as % of service exports) in Uganda?
Offer a terse response. 3.51. In the year 2011, what is the difference between the Balance of Payment (as % of service exports) of Montenegro and Balance of Payment (as % of service exports) of Uganda?
Provide a succinct answer. -3.98. In the year 2012, what is the difference between the Balance of Payment (as % of service exports) in Armenia and Balance of Payment (as % of service exports) in Grenada?
Provide a succinct answer. -3.57. In the year 2012, what is the difference between the Balance of Payment (as % of service exports) in Armenia and Balance of Payment (as % of service exports) in Montenegro?
Make the answer very short. 2.04. In the year 2012, what is the difference between the Balance of Payment (as % of service exports) in Armenia and Balance of Payment (as % of service exports) in Uganda?
Keep it short and to the point. -3.03. In the year 2012, what is the difference between the Balance of Payment (as % of service exports) of Grenada and Balance of Payment (as % of service exports) of Montenegro?
Offer a terse response. 5.61. In the year 2012, what is the difference between the Balance of Payment (as % of service exports) of Grenada and Balance of Payment (as % of service exports) of Uganda?
Provide a short and direct response. 0.54. In the year 2012, what is the difference between the Balance of Payment (as % of service exports) in Montenegro and Balance of Payment (as % of service exports) in Uganda?
Ensure brevity in your answer.  -5.07. In the year 2013, what is the difference between the Balance of Payment (as % of service exports) of Armenia and Balance of Payment (as % of service exports) of Grenada?
Make the answer very short. -3.16. In the year 2013, what is the difference between the Balance of Payment (as % of service exports) of Armenia and Balance of Payment (as % of service exports) of Montenegro?
Ensure brevity in your answer.  2.8. In the year 2013, what is the difference between the Balance of Payment (as % of service exports) of Armenia and Balance of Payment (as % of service exports) of Uganda?
Offer a very short reply. -6.57. In the year 2013, what is the difference between the Balance of Payment (as % of service exports) in Grenada and Balance of Payment (as % of service exports) in Montenegro?
Provide a short and direct response. 5.96. In the year 2013, what is the difference between the Balance of Payment (as % of service exports) in Grenada and Balance of Payment (as % of service exports) in Uganda?
Your response must be concise. -3.41. In the year 2013, what is the difference between the Balance of Payment (as % of service exports) of Montenegro and Balance of Payment (as % of service exports) of Uganda?
Your answer should be very brief. -9.37. What is the ratio of the Balance of Payment (as % of service exports) of Armenia in 2007 to that in 2008?
Give a very brief answer. 0.84. What is the ratio of the Balance of Payment (as % of service exports) in Grenada in 2007 to that in 2008?
Your response must be concise. 0.93. What is the ratio of the Balance of Payment (as % of service exports) in Montenegro in 2007 to that in 2008?
Your response must be concise. 1.12. What is the ratio of the Balance of Payment (as % of service exports) in Uganda in 2007 to that in 2008?
Keep it short and to the point. 0.76. What is the ratio of the Balance of Payment (as % of service exports) of Armenia in 2007 to that in 2009?
Provide a succinct answer. 0.92. What is the ratio of the Balance of Payment (as % of service exports) in Grenada in 2007 to that in 2009?
Offer a terse response. 0.82. What is the ratio of the Balance of Payment (as % of service exports) in Montenegro in 2007 to that in 2009?
Ensure brevity in your answer.  1.25. What is the ratio of the Balance of Payment (as % of service exports) in Uganda in 2007 to that in 2009?
Offer a very short reply. 1.01. What is the ratio of the Balance of Payment (as % of service exports) in Armenia in 2007 to that in 2010?
Your response must be concise. 0.93. What is the ratio of the Balance of Payment (as % of service exports) in Grenada in 2007 to that in 2010?
Give a very brief answer. 0.85. What is the ratio of the Balance of Payment (as % of service exports) of Montenegro in 2007 to that in 2010?
Your answer should be compact. 1.2. What is the ratio of the Balance of Payment (as % of service exports) of Uganda in 2007 to that in 2010?
Your response must be concise. 0.83. What is the ratio of the Balance of Payment (as % of service exports) of Armenia in 2007 to that in 2011?
Make the answer very short. 1.17. What is the ratio of the Balance of Payment (as % of service exports) of Grenada in 2007 to that in 2011?
Your response must be concise. 0.87. What is the ratio of the Balance of Payment (as % of service exports) of Montenegro in 2007 to that in 2011?
Your answer should be compact. 1.27. What is the ratio of the Balance of Payment (as % of service exports) in Uganda in 2007 to that in 2011?
Provide a short and direct response. 0.94. What is the ratio of the Balance of Payment (as % of service exports) of Armenia in 2007 to that in 2012?
Offer a very short reply. 1.27. What is the ratio of the Balance of Payment (as % of service exports) in Grenada in 2007 to that in 2012?
Provide a short and direct response. 0.97. What is the ratio of the Balance of Payment (as % of service exports) in Montenegro in 2007 to that in 2012?
Your answer should be compact. 1.21. What is the ratio of the Balance of Payment (as % of service exports) of Uganda in 2007 to that in 2012?
Your response must be concise. 0.84. What is the ratio of the Balance of Payment (as % of service exports) in Armenia in 2007 to that in 2013?
Offer a terse response. 1.17. What is the ratio of the Balance of Payment (as % of service exports) in Grenada in 2007 to that in 2013?
Provide a succinct answer. 0.94. What is the ratio of the Balance of Payment (as % of service exports) of Montenegro in 2007 to that in 2013?
Your answer should be very brief. 1.2. What is the ratio of the Balance of Payment (as % of service exports) in Uganda in 2007 to that in 2013?
Ensure brevity in your answer.  0.63. What is the ratio of the Balance of Payment (as % of service exports) of Armenia in 2008 to that in 2009?
Ensure brevity in your answer.  1.1. What is the ratio of the Balance of Payment (as % of service exports) of Grenada in 2008 to that in 2009?
Your response must be concise. 0.88. What is the ratio of the Balance of Payment (as % of service exports) of Montenegro in 2008 to that in 2009?
Give a very brief answer. 1.12. What is the ratio of the Balance of Payment (as % of service exports) of Uganda in 2008 to that in 2009?
Ensure brevity in your answer.  1.32. What is the ratio of the Balance of Payment (as % of service exports) of Armenia in 2008 to that in 2010?
Provide a succinct answer. 1.11. What is the ratio of the Balance of Payment (as % of service exports) of Grenada in 2008 to that in 2010?
Provide a succinct answer. 0.91. What is the ratio of the Balance of Payment (as % of service exports) in Montenegro in 2008 to that in 2010?
Your answer should be compact. 1.07. What is the ratio of the Balance of Payment (as % of service exports) in Uganda in 2008 to that in 2010?
Offer a very short reply. 1.09. What is the ratio of the Balance of Payment (as % of service exports) of Armenia in 2008 to that in 2011?
Your response must be concise. 1.39. What is the ratio of the Balance of Payment (as % of service exports) in Grenada in 2008 to that in 2011?
Provide a succinct answer. 0.94. What is the ratio of the Balance of Payment (as % of service exports) of Montenegro in 2008 to that in 2011?
Provide a short and direct response. 1.14. What is the ratio of the Balance of Payment (as % of service exports) in Uganda in 2008 to that in 2011?
Keep it short and to the point. 1.23. What is the ratio of the Balance of Payment (as % of service exports) in Armenia in 2008 to that in 2012?
Give a very brief answer. 1.51. What is the ratio of the Balance of Payment (as % of service exports) in Grenada in 2008 to that in 2012?
Give a very brief answer. 1.04. What is the ratio of the Balance of Payment (as % of service exports) of Montenegro in 2008 to that in 2012?
Make the answer very short. 1.08. What is the ratio of the Balance of Payment (as % of service exports) of Uganda in 2008 to that in 2012?
Offer a very short reply. 1.09. What is the ratio of the Balance of Payment (as % of service exports) of Armenia in 2008 to that in 2013?
Offer a terse response. 1.4. What is the ratio of the Balance of Payment (as % of service exports) in Grenada in 2008 to that in 2013?
Your answer should be compact. 1.01. What is the ratio of the Balance of Payment (as % of service exports) in Montenegro in 2008 to that in 2013?
Provide a succinct answer. 1.08. What is the ratio of the Balance of Payment (as % of service exports) in Uganda in 2008 to that in 2013?
Your answer should be compact. 0.82. What is the ratio of the Balance of Payment (as % of service exports) in Armenia in 2009 to that in 2010?
Provide a succinct answer. 1.01. What is the ratio of the Balance of Payment (as % of service exports) in Grenada in 2009 to that in 2010?
Give a very brief answer. 1.03. What is the ratio of the Balance of Payment (as % of service exports) in Montenegro in 2009 to that in 2010?
Give a very brief answer. 0.96. What is the ratio of the Balance of Payment (as % of service exports) in Uganda in 2009 to that in 2010?
Offer a very short reply. 0.82. What is the ratio of the Balance of Payment (as % of service exports) in Armenia in 2009 to that in 2011?
Provide a succinct answer. 1.26. What is the ratio of the Balance of Payment (as % of service exports) in Grenada in 2009 to that in 2011?
Your answer should be very brief. 1.07. What is the ratio of the Balance of Payment (as % of service exports) of Uganda in 2009 to that in 2011?
Ensure brevity in your answer.  0.93. What is the ratio of the Balance of Payment (as % of service exports) of Armenia in 2009 to that in 2012?
Offer a very short reply. 1.37. What is the ratio of the Balance of Payment (as % of service exports) in Grenada in 2009 to that in 2012?
Provide a short and direct response. 1.18. What is the ratio of the Balance of Payment (as % of service exports) in Uganda in 2009 to that in 2012?
Offer a very short reply. 0.83. What is the ratio of the Balance of Payment (as % of service exports) in Armenia in 2009 to that in 2013?
Your response must be concise. 1.27. What is the ratio of the Balance of Payment (as % of service exports) of Grenada in 2009 to that in 2013?
Provide a short and direct response. 1.15. What is the ratio of the Balance of Payment (as % of service exports) of Montenegro in 2009 to that in 2013?
Ensure brevity in your answer.  0.96. What is the ratio of the Balance of Payment (as % of service exports) of Uganda in 2009 to that in 2013?
Ensure brevity in your answer.  0.62. What is the ratio of the Balance of Payment (as % of service exports) of Armenia in 2010 to that in 2011?
Provide a succinct answer. 1.25. What is the ratio of the Balance of Payment (as % of service exports) of Grenada in 2010 to that in 2011?
Provide a short and direct response. 1.03. What is the ratio of the Balance of Payment (as % of service exports) in Montenegro in 2010 to that in 2011?
Your answer should be very brief. 1.06. What is the ratio of the Balance of Payment (as % of service exports) of Uganda in 2010 to that in 2011?
Your response must be concise. 1.13. What is the ratio of the Balance of Payment (as % of service exports) in Armenia in 2010 to that in 2012?
Your answer should be compact. 1.36. What is the ratio of the Balance of Payment (as % of service exports) in Grenada in 2010 to that in 2012?
Offer a very short reply. 1.15. What is the ratio of the Balance of Payment (as % of service exports) of Armenia in 2010 to that in 2013?
Give a very brief answer. 1.26. What is the ratio of the Balance of Payment (as % of service exports) in Grenada in 2010 to that in 2013?
Make the answer very short. 1.11. What is the ratio of the Balance of Payment (as % of service exports) in Montenegro in 2010 to that in 2013?
Your answer should be very brief. 1. What is the ratio of the Balance of Payment (as % of service exports) in Uganda in 2010 to that in 2013?
Offer a very short reply. 0.75. What is the ratio of the Balance of Payment (as % of service exports) of Armenia in 2011 to that in 2012?
Keep it short and to the point. 1.09. What is the ratio of the Balance of Payment (as % of service exports) in Grenada in 2011 to that in 2012?
Make the answer very short. 1.11. What is the ratio of the Balance of Payment (as % of service exports) of Montenegro in 2011 to that in 2012?
Make the answer very short. 0.95. What is the ratio of the Balance of Payment (as % of service exports) in Uganda in 2011 to that in 2012?
Make the answer very short. 0.89. What is the ratio of the Balance of Payment (as % of service exports) in Grenada in 2011 to that in 2013?
Ensure brevity in your answer.  1.08. What is the ratio of the Balance of Payment (as % of service exports) of Montenegro in 2011 to that in 2013?
Your answer should be very brief. 0.95. What is the ratio of the Balance of Payment (as % of service exports) of Uganda in 2011 to that in 2013?
Keep it short and to the point. 0.66. What is the ratio of the Balance of Payment (as % of service exports) of Armenia in 2012 to that in 2013?
Make the answer very short. 0.92. What is the ratio of the Balance of Payment (as % of service exports) of Grenada in 2012 to that in 2013?
Your answer should be very brief. 0.97. What is the ratio of the Balance of Payment (as % of service exports) of Montenegro in 2012 to that in 2013?
Offer a terse response. 0.99. What is the ratio of the Balance of Payment (as % of service exports) in Uganda in 2012 to that in 2013?
Provide a short and direct response. 0.75. What is the difference between the highest and the second highest Balance of Payment (as % of service exports) in Armenia?
Offer a very short reply. 1.38. What is the difference between the highest and the second highest Balance of Payment (as % of service exports) of Grenada?
Provide a short and direct response. 0.5. What is the difference between the highest and the second highest Balance of Payment (as % of service exports) in Uganda?
Your response must be concise. 3.13. What is the difference between the highest and the lowest Balance of Payment (as % of service exports) of Armenia?
Your response must be concise. 5.08. What is the difference between the highest and the lowest Balance of Payment (as % of service exports) of Grenada?
Your answer should be very brief. 2.89. What is the difference between the highest and the lowest Balance of Payment (as % of service exports) in Montenegro?
Keep it short and to the point. 2.02. What is the difference between the highest and the lowest Balance of Payment (as % of service exports) in Uganda?
Your answer should be very brief. 6.58. 